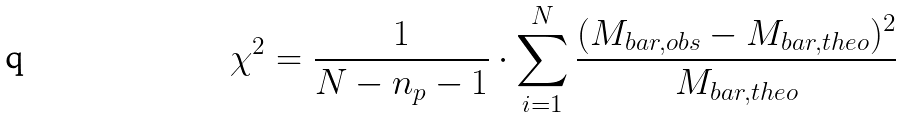Convert formula to latex. <formula><loc_0><loc_0><loc_500><loc_500>\chi ^ { 2 } = \frac { 1 } { N - n _ { p } - 1 } \cdot \sum _ { i = 1 } ^ { N } \frac { ( M _ { b a r , o b s } - M _ { b a r , t h e o } ) ^ { 2 } } { M _ { b a r , t h e o } }</formula> 